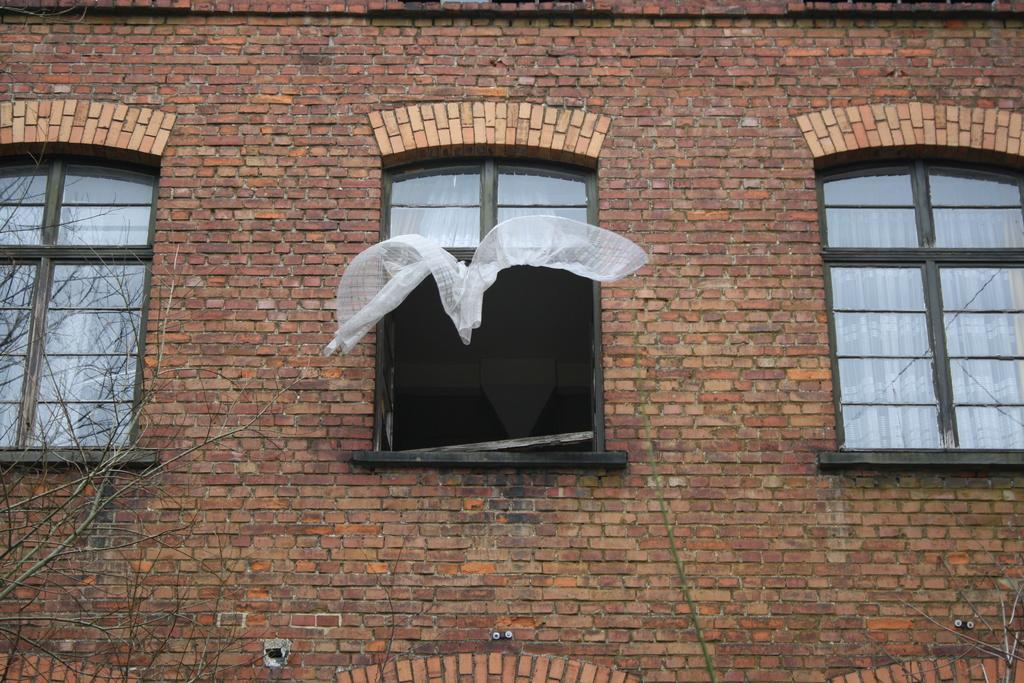What type of structure is visible in the image? There is a building in the image. What feature can be seen on the building? The building has windows. What is inside the windows of the building? There are white curtains in the windows. What material is the wall of the building made of? The wall of the building is made of bricks. What type of ornament is hanging from the ceiling in the image? There is no ornament hanging from the ceiling in the image; it only shows a building with windows, white curtains, and a brick wall. 